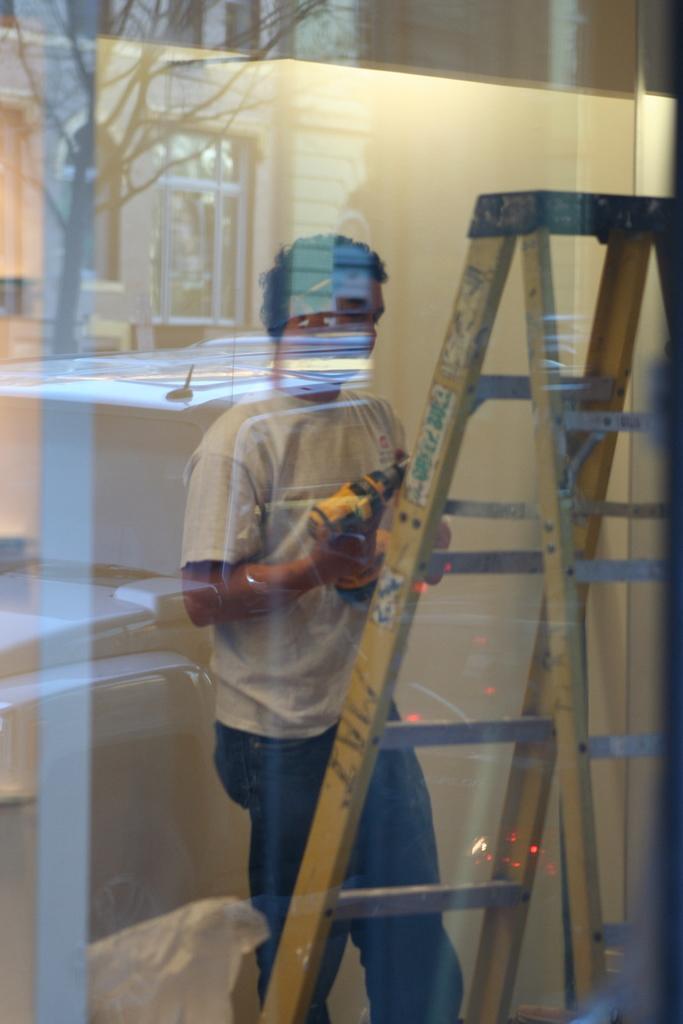Could you give a brief overview of what you see in this image? In this image there is a glass door, inside the glass door there is a person holding a drilling machine, there is a ladder and a white color object, on the glass door there are reflections of a tree and a building. 